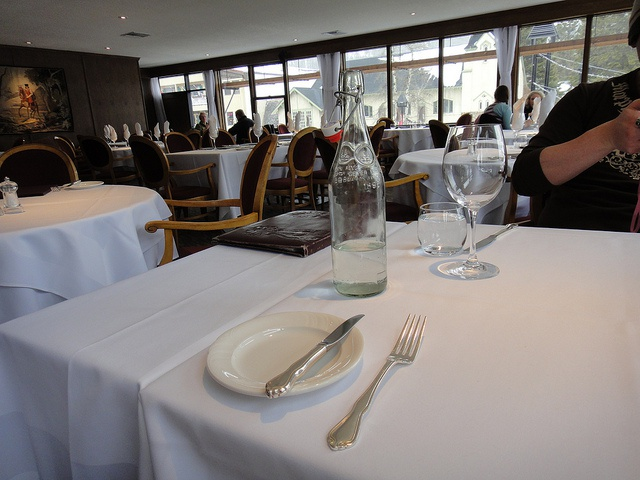Describe the objects in this image and their specific colors. I can see dining table in gray and darkgray tones, people in gray, black, maroon, and brown tones, bottle in gray, darkgray, and black tones, chair in gray, black, and maroon tones, and wine glass in gray, darkgray, lightgray, and black tones in this image. 